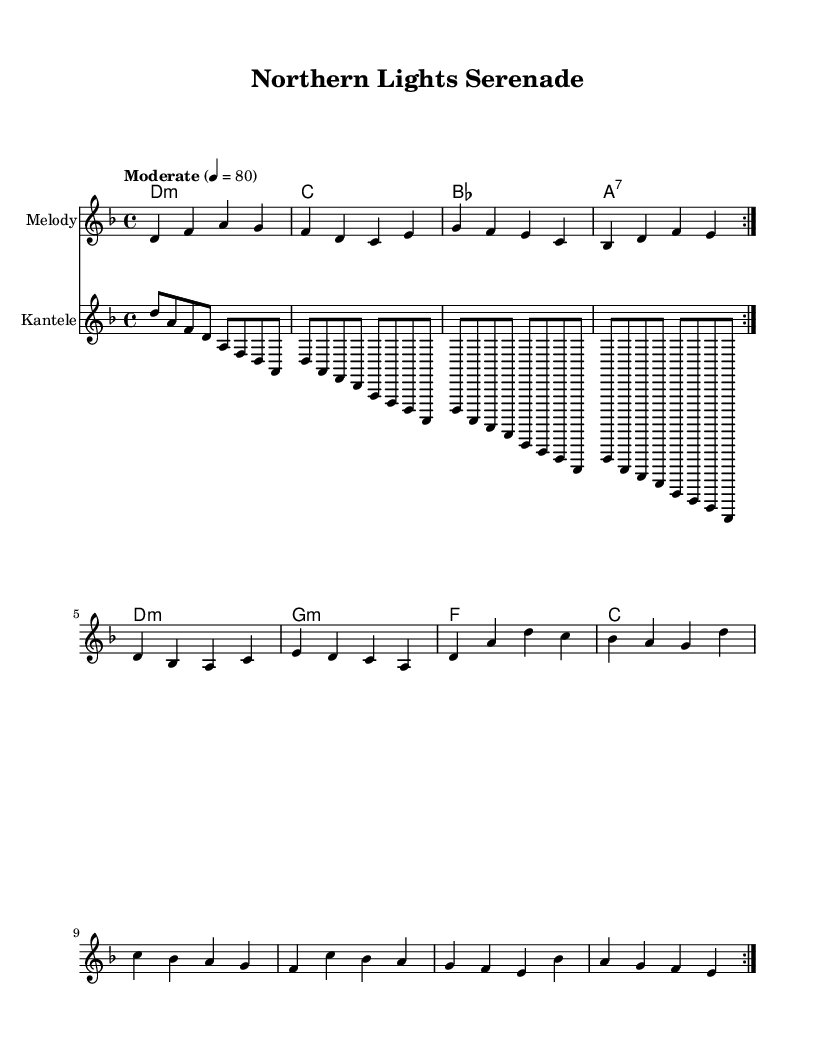What is the key signature of this music? The key signature indicated is D minor, which has one flat (B flat). This can be identified by looking at the key signature notation at the beginning of the staff.
Answer: D minor What is the time signature of this piece? The time signature is 4/4, which denotes four beats per measure. This can be determined by examining the top numbers in the time signature indicator that appears at the beginning of the score.
Answer: 4/4 What is the tempo marking for this composition? The tempo marking states "Moderate" with a metronome marking of 80 beats per minute. It is placed at the beginning of the score indicating the intended speed for the performance.
Answer: Moderate 4 = 80 How many measures are repeated in the melody section? The melody section contains a repeat sign, indicating that the section is meant to be played twice. This is visually represented by the repeat indication at the beginning of the melody.
Answer: 2 What type of chord is the first chord in the harmony? The first chord is a D minor chord, as indicated by the "D:m" notation in the chord section at the beginning of the piece. This tells us the quality of the chord being played.
Answer: D:m What instruments are indicated in this score? The score lists three parts: ChordNames, Melody, and Kantele. Each part is labeled accordingly, showing that there is a harmony part, a main melody, and a kantele part specifically in the score.
Answer: ChordNames, Melody, Kantele Which folk instrument is prominently featured in this piece? The kantele, a traditional Finnish string instrument, is specifically mentioned as part of the instrumentation in the score. Its unique sound adds a Nordic folk element that is incorporated into the piece.
Answer: Kantele 